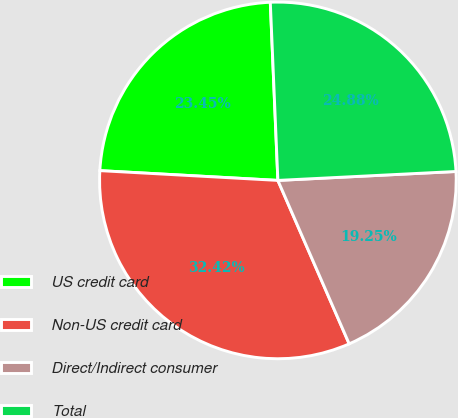<chart> <loc_0><loc_0><loc_500><loc_500><pie_chart><fcel>US credit card<fcel>Non-US credit card<fcel>Direct/Indirect consumer<fcel>Total<nl><fcel>23.45%<fcel>32.42%<fcel>19.25%<fcel>24.88%<nl></chart> 